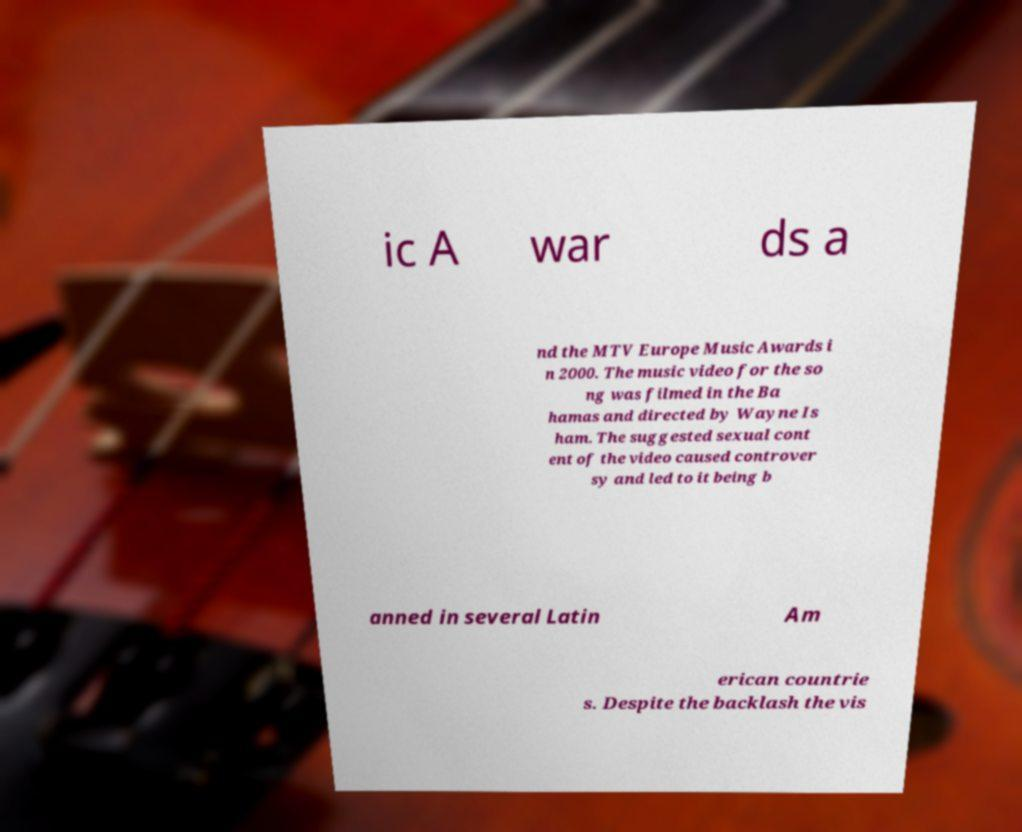Please read and relay the text visible in this image. What does it say? ic A war ds a nd the MTV Europe Music Awards i n 2000. The music video for the so ng was filmed in the Ba hamas and directed by Wayne Is ham. The suggested sexual cont ent of the video caused controver sy and led to it being b anned in several Latin Am erican countrie s. Despite the backlash the vis 